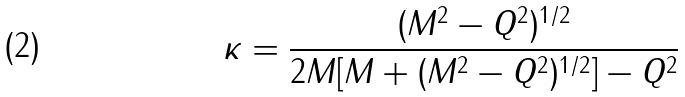Convert formula to latex. <formula><loc_0><loc_0><loc_500><loc_500>\kappa = \frac { ( M ^ { 2 } - Q ^ { 2 } ) ^ { 1 / 2 } } { 2 M [ M + ( M ^ { 2 } - Q ^ { 2 } ) ^ { 1 / 2 } ] - Q ^ { 2 } }</formula> 